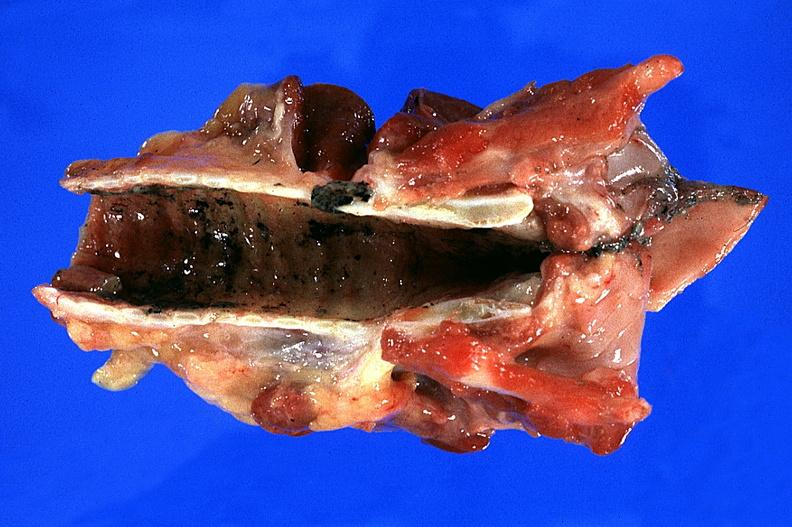do thermal burn smoke inhalation?
Answer the question using a single word or phrase. Yes 